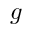<formula> <loc_0><loc_0><loc_500><loc_500>g</formula> 